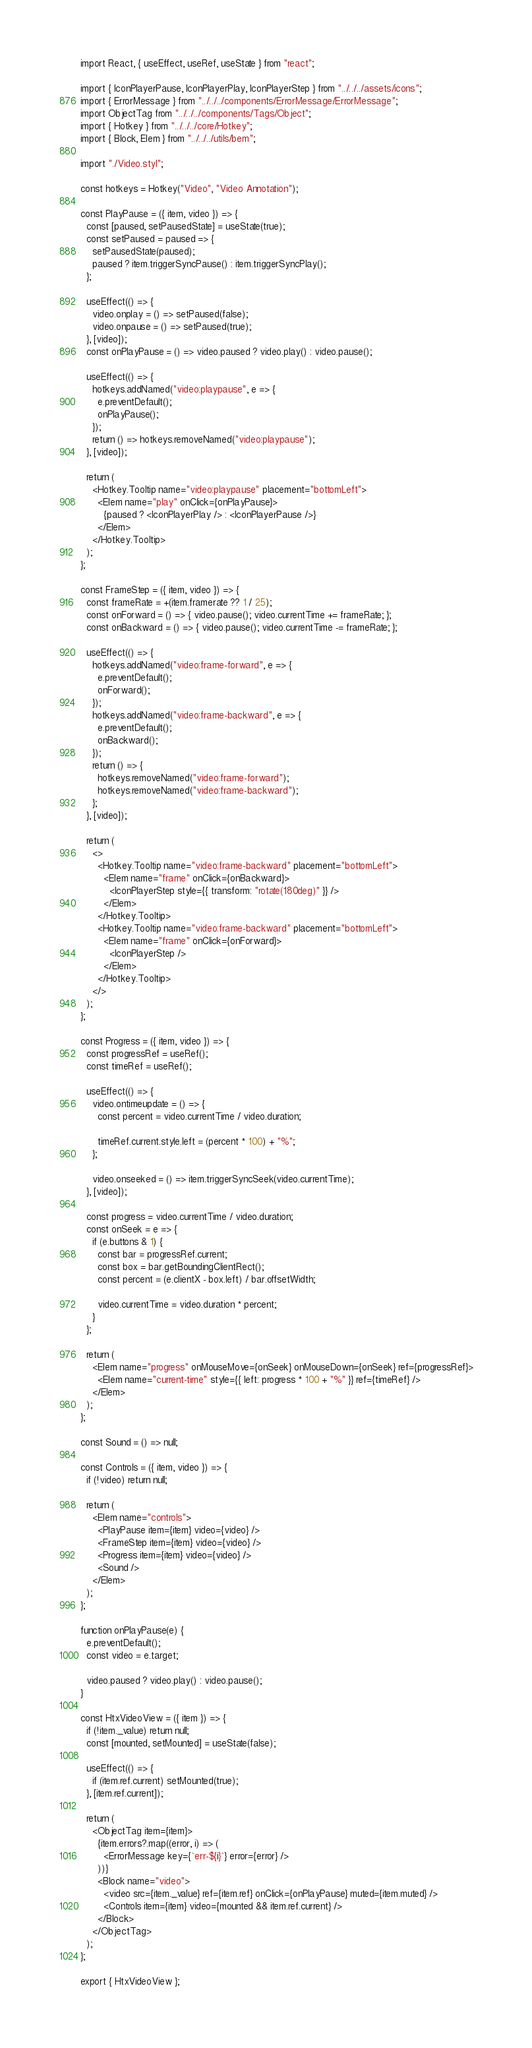Convert code to text. <code><loc_0><loc_0><loc_500><loc_500><_JavaScript_>import React, { useEffect, useRef, useState } from "react";

import { IconPlayerPause, IconPlayerPlay, IconPlayerStep } from "../../../assets/icons";
import { ErrorMessage } from "../../../components/ErrorMessage/ErrorMessage";
import ObjectTag from "../../../components/Tags/Object";
import { Hotkey } from "../../../core/Hotkey";
import { Block, Elem } from "../../../utils/bem";

import "./Video.styl";

const hotkeys = Hotkey("Video", "Video Annotation");

const PlayPause = ({ item, video }) => {
  const [paused, setPausedState] = useState(true);
  const setPaused = paused => {
    setPausedState(paused);
    paused ? item.triggerSyncPause() : item.triggerSyncPlay();
  };

  useEffect(() => {
    video.onplay = () => setPaused(false);
    video.onpause = () => setPaused(true);
  }, [video]);
  const onPlayPause = () => video.paused ? video.play() : video.pause();

  useEffect(() => {
    hotkeys.addNamed("video:playpause", e => {
      e.preventDefault();
      onPlayPause();
    });
    return () => hotkeys.removeNamed("video:playpause");
  }, [video]);

  return (
    <Hotkey.Tooltip name="video:playpause" placement="bottomLeft">
      <Elem name="play" onClick={onPlayPause}>
        {paused ? <IconPlayerPlay /> : <IconPlayerPause />}
      </Elem>
    </Hotkey.Tooltip>
  );
};

const FrameStep = ({ item, video }) => {
  const frameRate = +(item.framerate ?? 1 / 25);
  const onForward = () => { video.pause(); video.currentTime += frameRate; };
  const onBackward = () => { video.pause(); video.currentTime -= frameRate; };

  useEffect(() => {
    hotkeys.addNamed("video:frame-forward", e => {
      e.preventDefault();
      onForward();
    });
    hotkeys.addNamed("video:frame-backward", e => {
      e.preventDefault();
      onBackward();
    });
    return () => {
      hotkeys.removeNamed("video:frame-forward");
      hotkeys.removeNamed("video:frame-backward");
    };
  }, [video]);

  return (
    <>
      <Hotkey.Tooltip name="video:frame-backward" placement="bottomLeft">
        <Elem name="frame" onClick={onBackward}>
          <IconPlayerStep style={{ transform: "rotate(180deg)" }} />
        </Elem>
      </Hotkey.Tooltip>
      <Hotkey.Tooltip name="video:frame-backward" placement="bottomLeft">
        <Elem name="frame" onClick={onForward}>
          <IconPlayerStep />
        </Elem>
      </Hotkey.Tooltip>
    </>
  );
};

const Progress = ({ item, video }) => {
  const progressRef = useRef();
  const timeRef = useRef();

  useEffect(() => {
    video.ontimeupdate = () => {
      const percent = video.currentTime / video.duration;

      timeRef.current.style.left = (percent * 100) + "%";
    };

    video.onseeked = () => item.triggerSyncSeek(video.currentTime);
  }, [video]);

  const progress = video.currentTime / video.duration;
  const onSeek = e => {
    if (e.buttons & 1) {
      const bar = progressRef.current;
      const box = bar.getBoundingClientRect();
      const percent = (e.clientX - box.left) / bar.offsetWidth;

      video.currentTime = video.duration * percent;
    }
  };

  return (
    <Elem name="progress" onMouseMove={onSeek} onMouseDown={onSeek} ref={progressRef}>
      <Elem name="current-time" style={{ left: progress * 100 + "%" }} ref={timeRef} />
    </Elem>
  );
};

const Sound = () => null;

const Controls = ({ item, video }) => {
  if (!video) return null;

  return (
    <Elem name="controls">
      <PlayPause item={item} video={video} />
      <FrameStep item={item} video={video} />
      <Progress item={item} video={video} />
      <Sound />
    </Elem>
  );
};

function onPlayPause(e) {
  e.preventDefault();
  const video = e.target;

  video.paused ? video.play() : video.pause();
}

const HtxVideoView = ({ item }) => {
  if (!item._value) return null;
  const [mounted, setMounted] = useState(false);

  useEffect(() => {
    if (item.ref.current) setMounted(true);
  }, [item.ref.current]);

  return (
    <ObjectTag item={item}>
      {item.errors?.map((error, i) => (
        <ErrorMessage key={`err-${i}`} error={error} />
      ))}
      <Block name="video">
        <video src={item._value} ref={item.ref} onClick={onPlayPause} muted={item.muted} />
        <Controls item={item} video={mounted && item.ref.current} />
      </Block>
    </ObjectTag>
  );
};

export { HtxVideoView };
</code> 